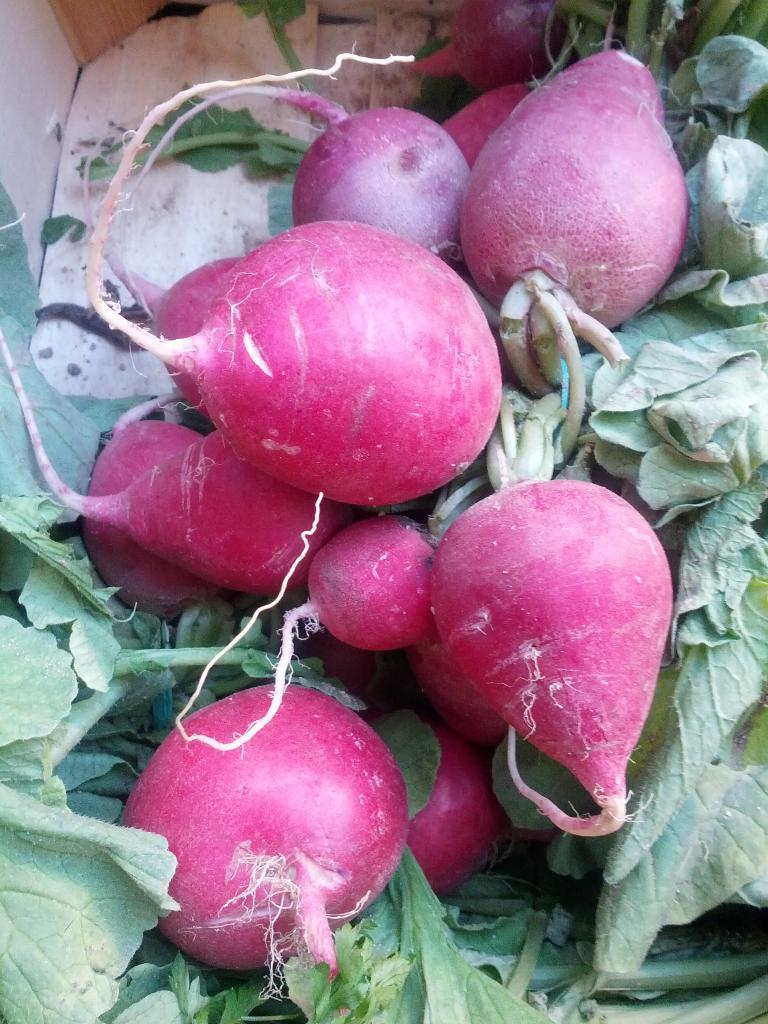What type of vegetables are in the image? There are turnip root vegetables in the image. What part of the turnip root vegetables is visible in the image? The turnip root vegetables have leaves that are visible in the image. What type of pencil can be seen in the image? There is no pencil present in the image; it features turnip root vegetables with leaves. 